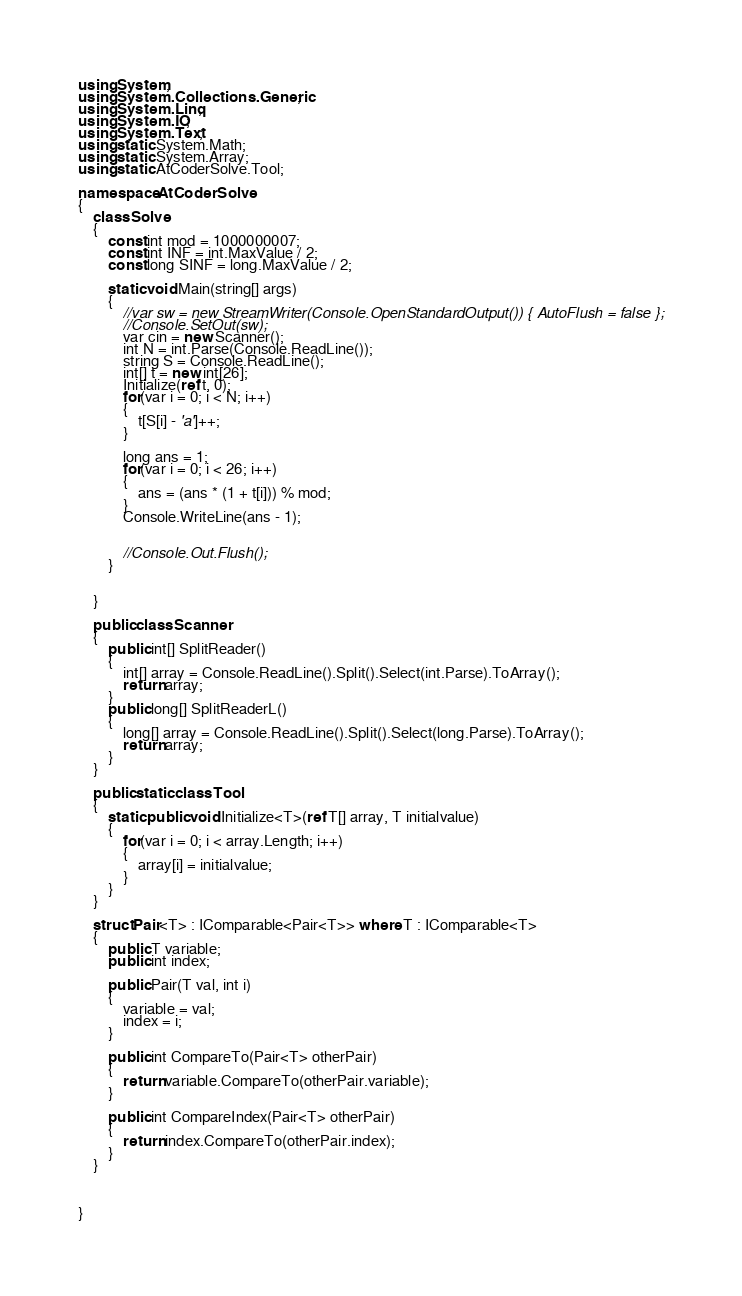Convert code to text. <code><loc_0><loc_0><loc_500><loc_500><_C#_>using System;
using System.Collections.Generic;
using System.Linq;
using System.IO;
using System.Text;
using static System.Math;
using static System.Array;
using static AtCoderSolve.Tool;

namespace AtCoderSolve
{
    class Solve
    {
        const int mod = 1000000007;
        const int INF = int.MaxValue / 2;
        const long SINF = long.MaxValue / 2;

        static void Main(string[] args)
        {
            //var sw = new StreamWriter(Console.OpenStandardOutput()) { AutoFlush = false };
            //Console.SetOut(sw);
            var cin = new Scanner();
            int N = int.Parse(Console.ReadLine());
            string S = Console.ReadLine();
            int[] t = new int[26];
            Initialize(ref t, 0);
            for(var i = 0; i < N; i++)
            {
                t[S[i] - 'a']++;
            }

            long ans = 1;
            for(var i = 0; i < 26; i++)
            {
                ans = (ans * (1 + t[i])) % mod;
            }
            Console.WriteLine(ans - 1);


            //Console.Out.Flush();
        }


    }

    public class Scanner
    {
        public int[] SplitReader()
        {
            int[] array = Console.ReadLine().Split().Select(int.Parse).ToArray();
            return array;
        }
        public long[] SplitReaderL()
        {
            long[] array = Console.ReadLine().Split().Select(long.Parse).ToArray();
            return array;
        }
    }

    public static class Tool
    {
        static public void Initialize<T>(ref T[] array, T initialvalue)
        {
            for(var i = 0; i < array.Length; i++)
            {
                array[i] = initialvalue;
            }
        }
    }

    struct Pair<T> : IComparable<Pair<T>> where T : IComparable<T>
    {
        public T variable;
        public int index;

        public Pair(T val, int i)
        {
            variable = val;
            index = i;
        }

        public int CompareTo(Pair<T> otherPair)
        {
            return variable.CompareTo(otherPair.variable);
        }

        public int CompareIndex(Pair<T> otherPair)
        {
            return index.CompareTo(otherPair.index);
        }
    }



}




</code> 